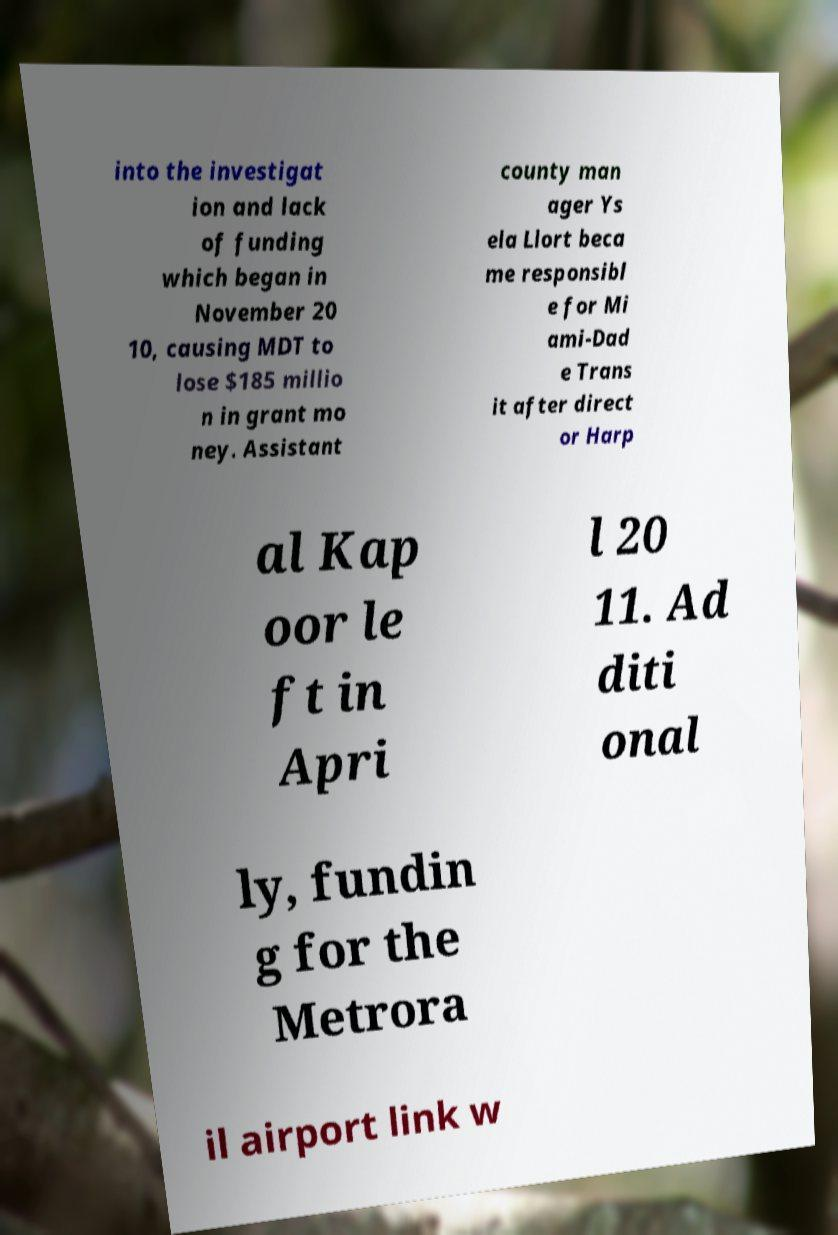Could you assist in decoding the text presented in this image and type it out clearly? into the investigat ion and lack of funding which began in November 20 10, causing MDT to lose $185 millio n in grant mo ney. Assistant county man ager Ys ela Llort beca me responsibl e for Mi ami-Dad e Trans it after direct or Harp al Kap oor le ft in Apri l 20 11. Ad diti onal ly, fundin g for the Metrora il airport link w 